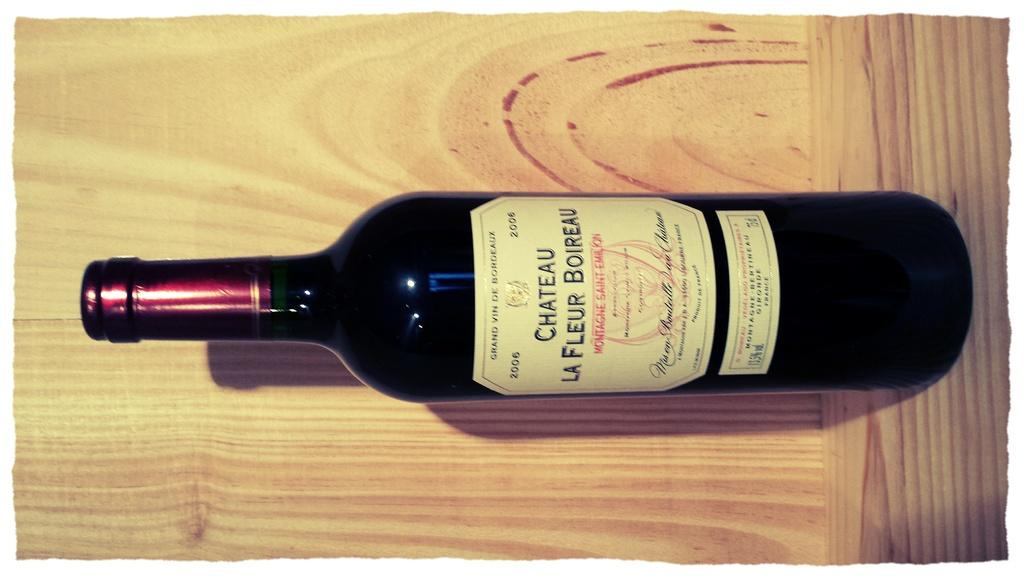<image>
Render a clear and concise summary of the photo. A bottle of Chateau La Fleur Boireau sits in a wooden crate. 